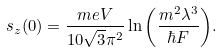Convert formula to latex. <formula><loc_0><loc_0><loc_500><loc_500>s _ { z } ( 0 ) = \frac { m e V } { 1 0 \sqrt { 3 } \pi ^ { 2 } } \ln { \left ( \frac { m ^ { 2 } \lambda ^ { 3 } } { \hbar { F } } \right ) } .</formula> 